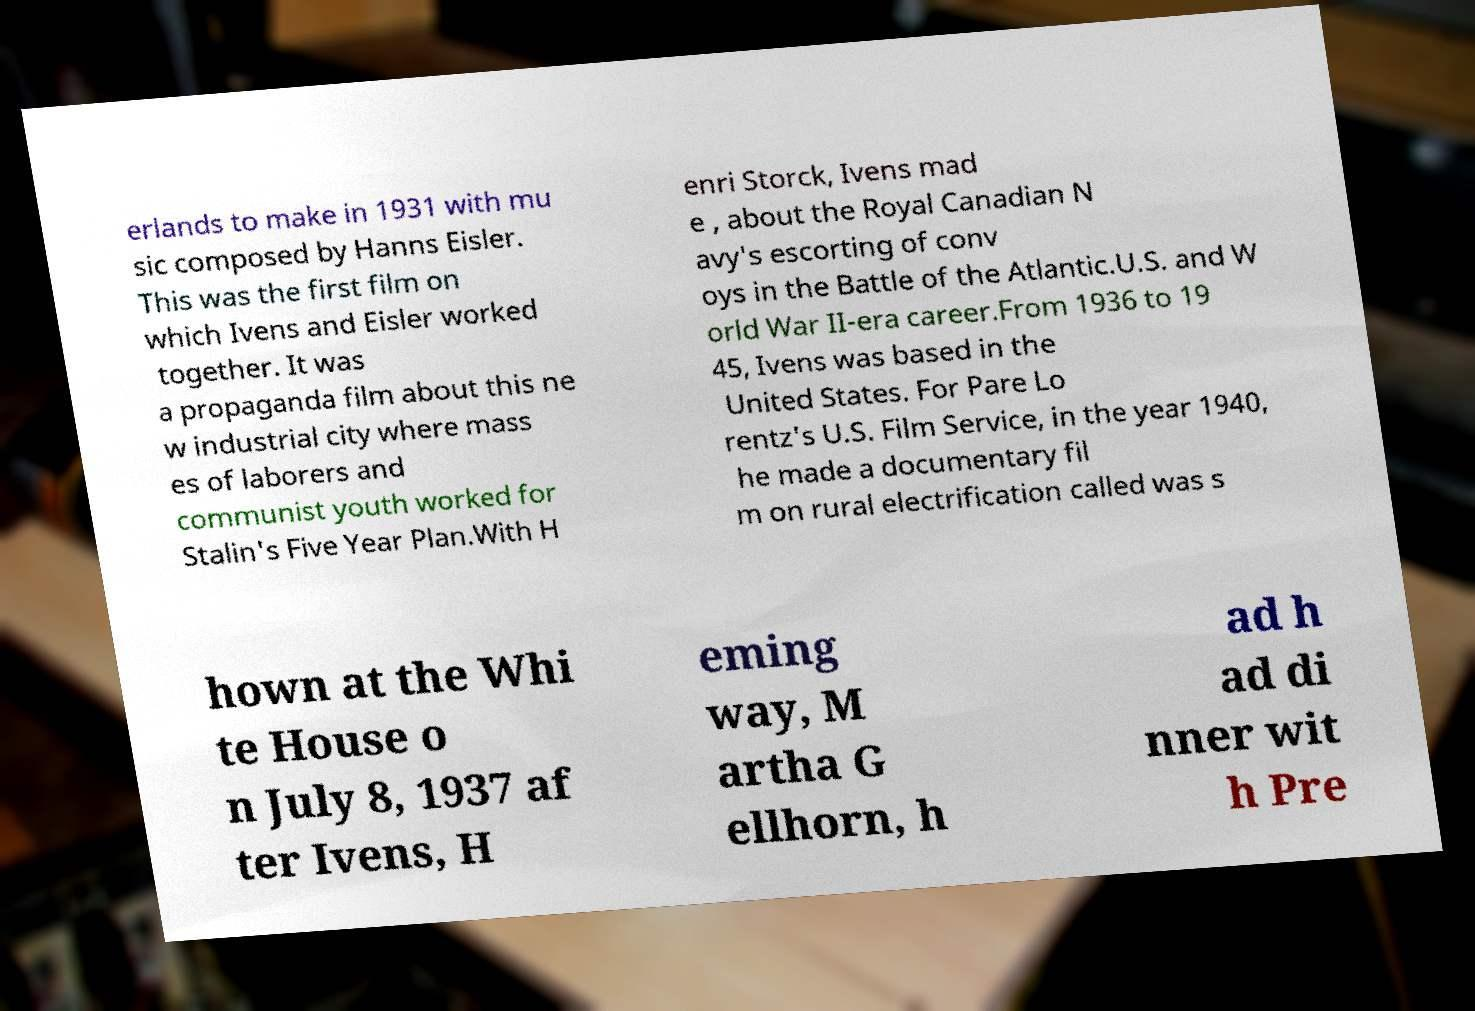Please identify and transcribe the text found in this image. erlands to make in 1931 with mu sic composed by Hanns Eisler. This was the first film on which Ivens and Eisler worked together. It was a propaganda film about this ne w industrial city where mass es of laborers and communist youth worked for Stalin's Five Year Plan.With H enri Storck, Ivens mad e , about the Royal Canadian N avy's escorting of conv oys in the Battle of the Atlantic.U.S. and W orld War II-era career.From 1936 to 19 45, Ivens was based in the United States. For Pare Lo rentz's U.S. Film Service, in the year 1940, he made a documentary fil m on rural electrification called was s hown at the Whi te House o n July 8, 1937 af ter Ivens, H eming way, M artha G ellhorn, h ad h ad di nner wit h Pre 